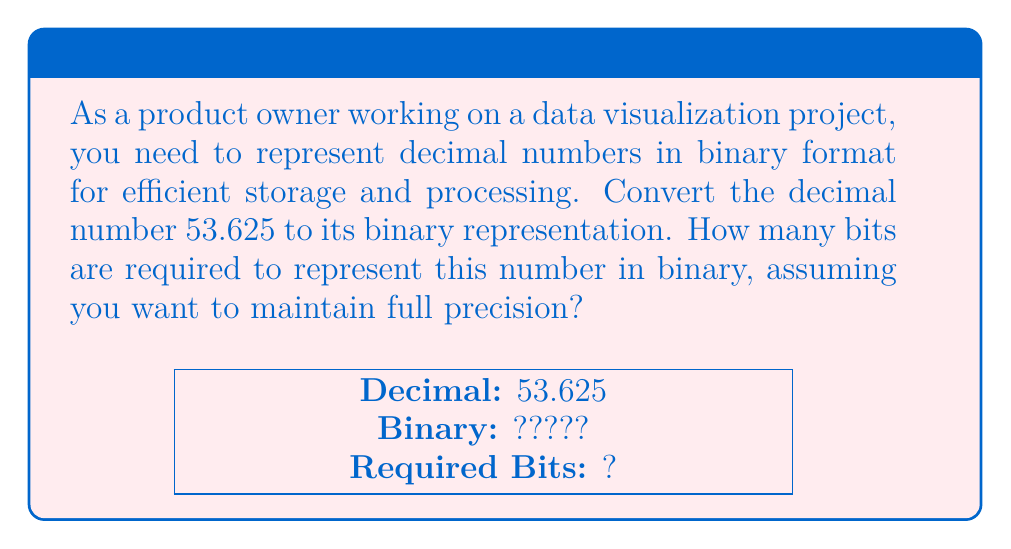Provide a solution to this math problem. Let's convert 53.625 to binary step by step:

1. Convert the integer part (53):
   $53 \div 2 = 26$ remainder $1$
   $26 \div 2 = 13$ remainder $0$
   $13 \div 2 = 6$  remainder $1$
   $6 \div 2 = 3$   remainder $0$
   $3 \div 2 = 1$   remainder $1$
   $1 \div 2 = 0$   remainder $1$
   
   Reading the remainders from bottom to top, we get: $53_{10} = 110101_2$

2. Convert the fractional part (0.625):
   $0.625 \times 2 = 1.25$ (integer part: 1)
   $0.25 \times 2 = 0.5$   (integer part: 0)
   $0.5 \times 2 = 1.0$    (integer part: 1)
   
   Reading the integer parts from top to bottom, we get: $0.625_{10} = 0.101_2$

3. Combine the integer and fractional parts:
   $53.625_{10} = 110101.101_2$

4. Count the bits:
   - Integer part: 6 bits
   - Fractional part: 3 bits
   - Total: 6 + 1 (for the decimal point) + 3 = 10 bits

Therefore, 10 bits are required to represent 53.625 in binary with full precision.
Answer: 10 bits 